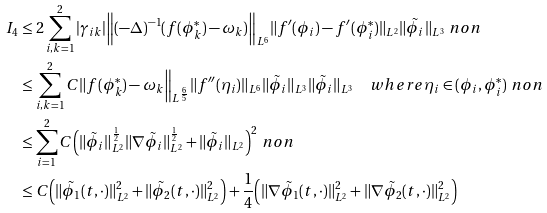Convert formula to latex. <formula><loc_0><loc_0><loc_500><loc_500>I _ { 4 } & \leq 2 \sum _ { i , k = 1 } ^ { 2 } | \gamma _ { i k } | \Big \| ( - \Delta ) ^ { - 1 } ( f ( \phi _ { k } ^ { \ast } ) - \omega _ { k } ) \Big \| _ { L ^ { 6 } } \| f ^ { \prime } ( \phi _ { i } ) - f ^ { \prime } ( \phi _ { i } ^ { \ast } ) \| _ { L ^ { 2 } } \| \tilde { \phi } _ { i } \| _ { L ^ { 3 } } \ n o n \\ & \leq \sum _ { i , k = 1 } ^ { 2 } C \| f ( \phi _ { k } ^ { \ast } ) - \omega _ { k } \Big \| _ { L ^ { \frac { 6 } { 5 } } } \| f ^ { \prime \prime } ( \eta _ { i } ) \| _ { L ^ { 6 } } \| \tilde { \phi } _ { i } \| _ { L ^ { 3 } } \| \tilde { \phi } _ { i } \| _ { L ^ { 3 } } \quad w h e r e \eta _ { i } \in ( \phi _ { i } , \phi _ { i } ^ { \ast } ) \ n o n \\ & \leq \sum _ { i = 1 } ^ { 2 } C \Big ( \| \tilde { \phi } _ { i } \| _ { L ^ { 2 } } ^ { \frac { 1 } { 2 } } \| \nabla \tilde { \phi } _ { i } \| _ { L ^ { 2 } } ^ { \frac { 1 } { 2 } } + \| \tilde { \phi } _ { i } \| _ { L ^ { 2 } } \Big ) ^ { 2 } \ n o n \\ & \leq C \Big ( \| \tilde { \phi } _ { 1 } ( t , \cdot ) \| _ { L ^ { 2 } } ^ { 2 } + \| \tilde { \phi } _ { 2 } ( t , \cdot ) \| _ { L ^ { 2 } } ^ { 2 } \Big ) + \frac { 1 } { 4 } \Big ( \| \nabla \tilde { \phi } _ { 1 } ( t , \cdot ) \| _ { L ^ { 2 } } ^ { 2 } + \| \nabla \tilde { \phi } _ { 2 } ( t , \cdot ) \| _ { L ^ { 2 } } ^ { 2 } \Big )</formula> 